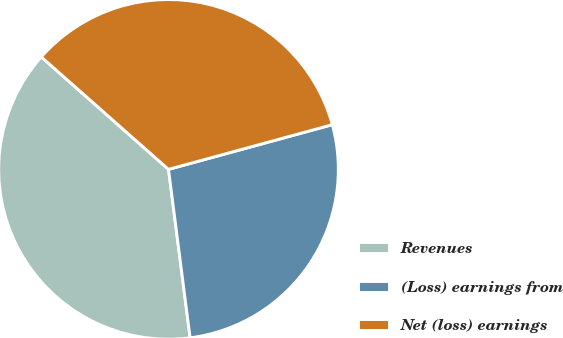Convert chart to OTSL. <chart><loc_0><loc_0><loc_500><loc_500><pie_chart><fcel>Revenues<fcel>(Loss) earnings from<fcel>Net (loss) earnings<nl><fcel>38.55%<fcel>27.21%<fcel>34.24%<nl></chart> 